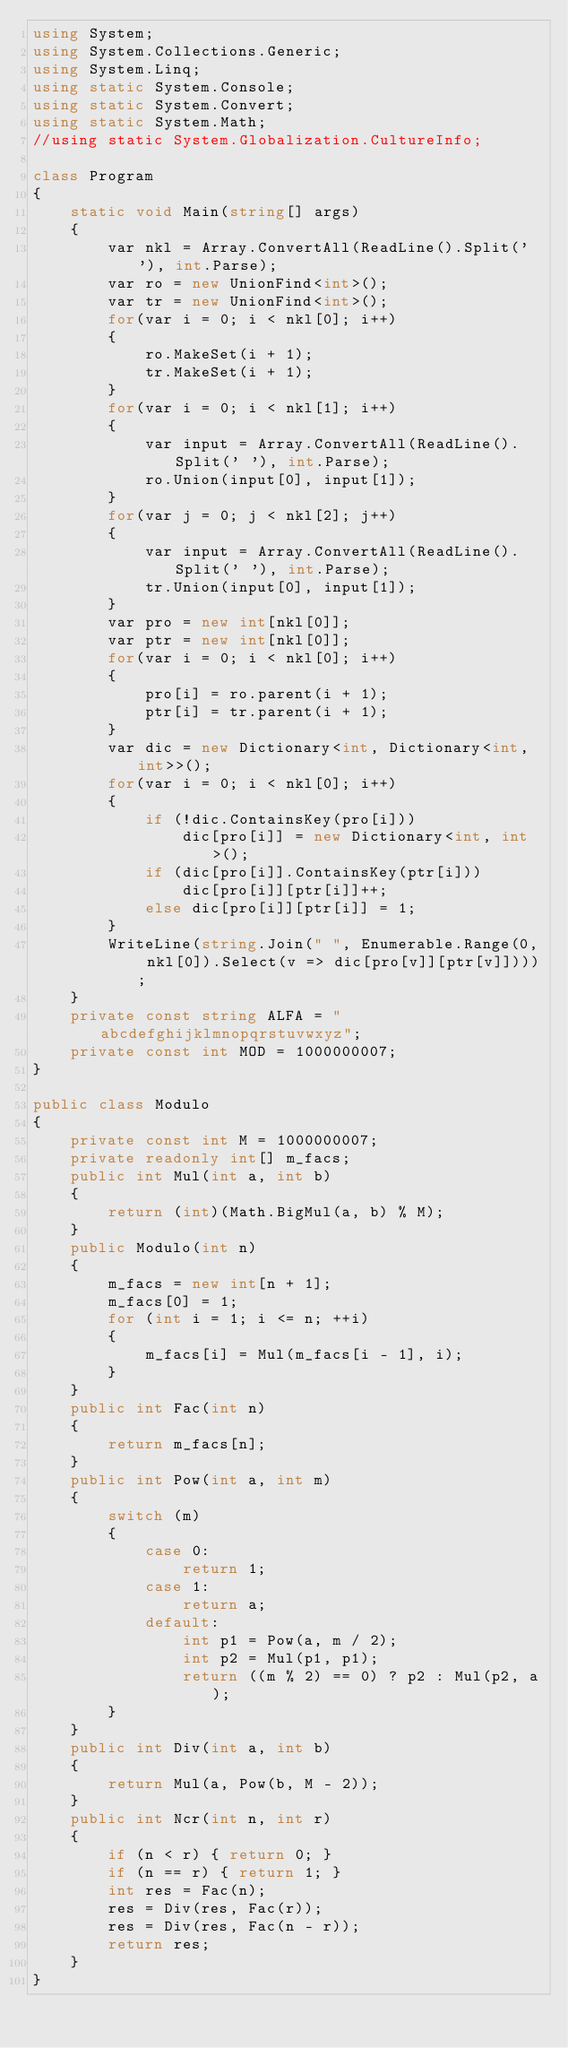Convert code to text. <code><loc_0><loc_0><loc_500><loc_500><_C#_>using System;
using System.Collections.Generic;
using System.Linq;
using static System.Console;
using static System.Convert;
using static System.Math;
//using static System.Globalization.CultureInfo;

class Program
{
    static void Main(string[] args)
    {
        var nkl = Array.ConvertAll(ReadLine().Split(' '), int.Parse);
        var ro = new UnionFind<int>();
        var tr = new UnionFind<int>();
        for(var i = 0; i < nkl[0]; i++)
        {
            ro.MakeSet(i + 1);
            tr.MakeSet(i + 1);
        }
        for(var i = 0; i < nkl[1]; i++)
        {
            var input = Array.ConvertAll(ReadLine().Split(' '), int.Parse);
            ro.Union(input[0], input[1]);
        }
        for(var j = 0; j < nkl[2]; j++)
        {
            var input = Array.ConvertAll(ReadLine().Split(' '), int.Parse);
            tr.Union(input[0], input[1]);
        }
        var pro = new int[nkl[0]];
        var ptr = new int[nkl[0]];
        for(var i = 0; i < nkl[0]; i++)
        {
            pro[i] = ro.parent(i + 1);
            ptr[i] = tr.parent(i + 1);
        }
        var dic = new Dictionary<int, Dictionary<int, int>>();
        for(var i = 0; i < nkl[0]; i++)
        {
            if (!dic.ContainsKey(pro[i]))
                dic[pro[i]] = new Dictionary<int, int>();
            if (dic[pro[i]].ContainsKey(ptr[i]))
                dic[pro[i]][ptr[i]]++;
            else dic[pro[i]][ptr[i]] = 1;
        }
        WriteLine(string.Join(" ", Enumerable.Range(0, nkl[0]).Select(v => dic[pro[v]][ptr[v]])));
    }
    private const string ALFA = "abcdefghijklmnopqrstuvwxyz";
    private const int MOD = 1000000007;
}

public class Modulo
{
    private const int M = 1000000007;
    private readonly int[] m_facs;
    public int Mul(int a, int b)
    {
        return (int)(Math.BigMul(a, b) % M);
    }
    public Modulo(int n)
    {
        m_facs = new int[n + 1];
        m_facs[0] = 1;
        for (int i = 1; i <= n; ++i)
        {
            m_facs[i] = Mul(m_facs[i - 1], i);
        }
    }
    public int Fac(int n)
    {
        return m_facs[n];
    }
    public int Pow(int a, int m)
    {
        switch (m)
        {
            case 0:
                return 1;
            case 1:
                return a;
            default:
                int p1 = Pow(a, m / 2);
                int p2 = Mul(p1, p1);
                return ((m % 2) == 0) ? p2 : Mul(p2, a);
        }
    }
    public int Div(int a, int b)
    {
        return Mul(a, Pow(b, M - 2));
    }
    public int Ncr(int n, int r)
    {
        if (n < r) { return 0; }
        if (n == r) { return 1; }
        int res = Fac(n);
        res = Div(res, Fac(r));
        res = Div(res, Fac(n - r));
        return res;
    }
}</code> 